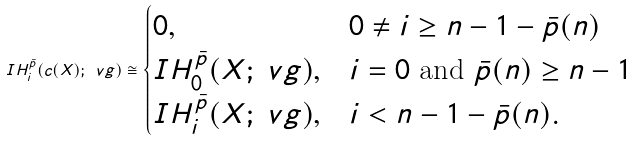<formula> <loc_0><loc_0><loc_500><loc_500>I H _ { i } ^ { \bar { p } } ( c ( X ) ; \ v g ) \cong \begin{cases} 0 , & 0 \neq i \geq n - 1 - \bar { p } ( n ) \\ I H _ { 0 } ^ { \bar { p } } ( X ; \ v g ) , & i = 0 \text { and } \bar { p } ( n ) \geq n - 1 \\ I H _ { i } ^ { \bar { p } } ( X ; \ v g ) , & i < n - 1 - \bar { p } ( n ) . \end{cases}</formula> 